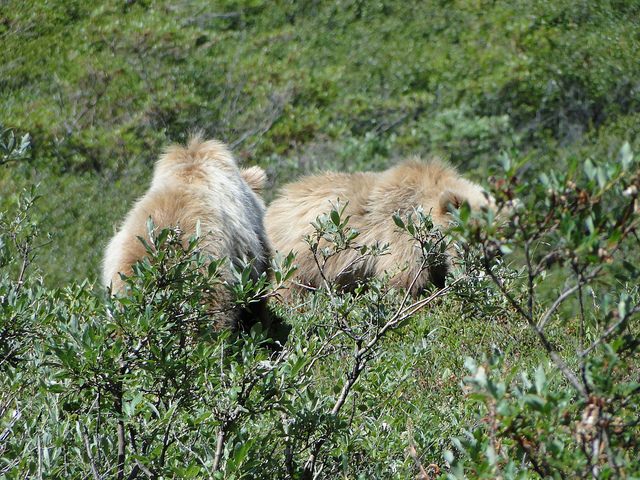What season does it look like in the image? The brightness and greenery present in the image suggest that it is taken during the spring or summer months when vegetation is most lush. What clues lead you to that conclusion? The vivid green leaves and the overall well-lit environment imply that it's a time of active plant growth, which typically occurs in the warmer, sunnier seasons. 